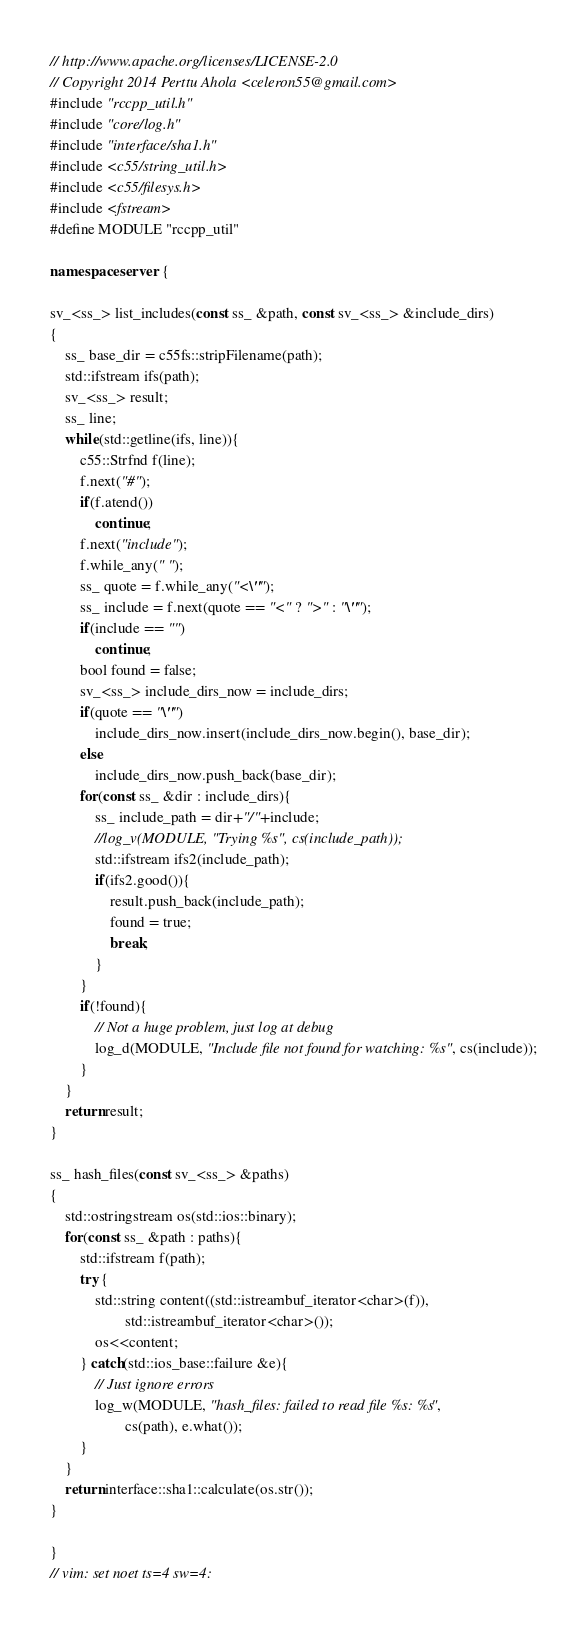Convert code to text. <code><loc_0><loc_0><loc_500><loc_500><_C++_>// http://www.apache.org/licenses/LICENSE-2.0
// Copyright 2014 Perttu Ahola <celeron55@gmail.com>
#include "rccpp_util.h"
#include "core/log.h"
#include "interface/sha1.h"
#include <c55/string_util.h>
#include <c55/filesys.h>
#include <fstream>
#define MODULE "rccpp_util"

namespace server {

sv_<ss_> list_includes(const ss_ &path, const sv_<ss_> &include_dirs)
{
	ss_ base_dir = c55fs::stripFilename(path);
	std::ifstream ifs(path);
	sv_<ss_> result;
	ss_ line;
	while(std::getline(ifs, line)){
		c55::Strfnd f(line);
		f.next("#");
		if(f.atend())
			continue;
		f.next("include");
		f.while_any(" ");
		ss_ quote = f.while_any("<\"");
		ss_ include = f.next(quote == "<" ? ">" : "\"");
		if(include == "")
			continue;
		bool found = false;
		sv_<ss_> include_dirs_now = include_dirs;
		if(quote == "\"")
			include_dirs_now.insert(include_dirs_now.begin(), base_dir);
		else
			include_dirs_now.push_back(base_dir);
		for(const ss_ &dir : include_dirs){
			ss_ include_path = dir+"/"+include;
			//log_v(MODULE, "Trying %s", cs(include_path));
			std::ifstream ifs2(include_path);
			if(ifs2.good()){
				result.push_back(include_path);
				found = true;
				break;
			}
		}
		if(!found){
			// Not a huge problem, just log at debug
			log_d(MODULE, "Include file not found for watching: %s", cs(include));
		}
	}
	return result;
}

ss_ hash_files(const sv_<ss_> &paths)
{
	std::ostringstream os(std::ios::binary);
	for(const ss_ &path : paths){
		std::ifstream f(path);
		try {
			std::string content((std::istreambuf_iterator<char>(f)),
					std::istreambuf_iterator<char>());
			os<<content;
		} catch(std::ios_base::failure &e){
			// Just ignore errors
			log_w(MODULE, "hash_files: failed to read file %s: %s",
					cs(path), e.what());
		}
	}
	return interface::sha1::calculate(os.str());
}

}
// vim: set noet ts=4 sw=4:
</code> 